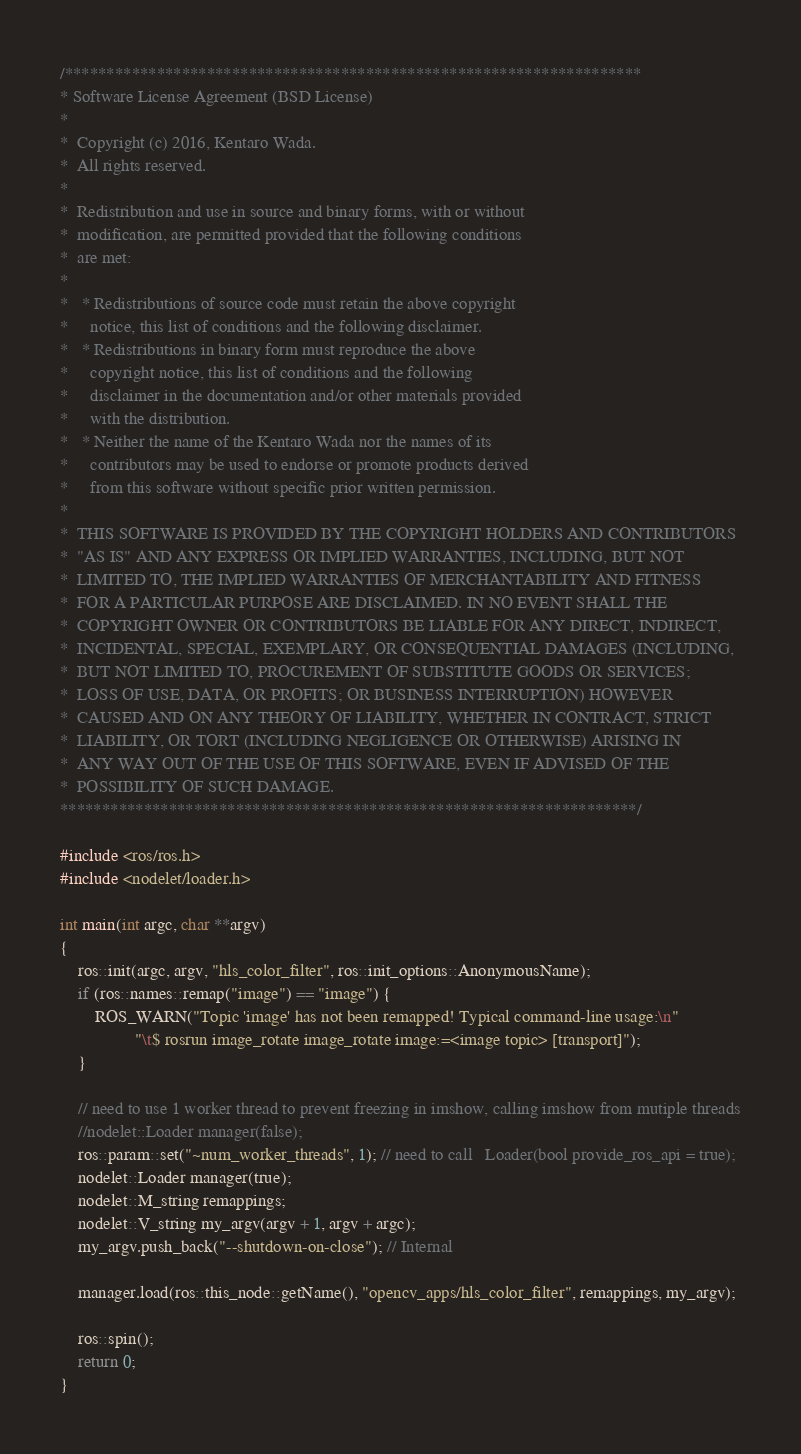Convert code to text. <code><loc_0><loc_0><loc_500><loc_500><_C++_>/*********************************************************************
* Software License Agreement (BSD License)
*
*  Copyright (c) 2016, Kentaro Wada.
*  All rights reserved.
*
*  Redistribution and use in source and binary forms, with or without
*  modification, are permitted provided that the following conditions
*  are met:
*
*   * Redistributions of source code must retain the above copyright
*     notice, this list of conditions and the following disclaimer.
*   * Redistributions in binary form must reproduce the above
*     copyright notice, this list of conditions and the following
*     disclaimer in the documentation and/or other materials provided
*     with the distribution.
*   * Neither the name of the Kentaro Wada nor the names of its
*     contributors may be used to endorse or promote products derived
*     from this software without specific prior written permission.
*
*  THIS SOFTWARE IS PROVIDED BY THE COPYRIGHT HOLDERS AND CONTRIBUTORS
*  "AS IS" AND ANY EXPRESS OR IMPLIED WARRANTIES, INCLUDING, BUT NOT
*  LIMITED TO, THE IMPLIED WARRANTIES OF MERCHANTABILITY AND FITNESS
*  FOR A PARTICULAR PURPOSE ARE DISCLAIMED. IN NO EVENT SHALL THE
*  COPYRIGHT OWNER OR CONTRIBUTORS BE LIABLE FOR ANY DIRECT, INDIRECT,
*  INCIDENTAL, SPECIAL, EXEMPLARY, OR CONSEQUENTIAL DAMAGES (INCLUDING,
*  BUT NOT LIMITED TO, PROCUREMENT OF SUBSTITUTE GOODS OR SERVICES;
*  LOSS OF USE, DATA, OR PROFITS; OR BUSINESS INTERRUPTION) HOWEVER
*  CAUSED AND ON ANY THEORY OF LIABILITY, WHETHER IN CONTRACT, STRICT
*  LIABILITY, OR TORT (INCLUDING NEGLIGENCE OR OTHERWISE) ARISING IN
*  ANY WAY OUT OF THE USE OF THIS SOFTWARE, EVEN IF ADVISED OF THE
*  POSSIBILITY OF SUCH DAMAGE.
*********************************************************************/

#include <ros/ros.h>
#include <nodelet/loader.h>

int main(int argc, char **argv)
{
    ros::init(argc, argv, "hls_color_filter", ros::init_options::AnonymousName);
    if (ros::names::remap("image") == "image") {
        ROS_WARN("Topic 'image' has not been remapped! Typical command-line usage:\n"
                 "\t$ rosrun image_rotate image_rotate image:=<image topic> [transport]");
    }

    // need to use 1 worker thread to prevent freezing in imshow, calling imshow from mutiple threads
    //nodelet::Loader manager(false);
    ros::param::set("~num_worker_threads", 1); // need to call   Loader(bool provide_ros_api = true);
    nodelet::Loader manager(true);
    nodelet::M_string remappings;
    nodelet::V_string my_argv(argv + 1, argv + argc);
    my_argv.push_back("--shutdown-on-close"); // Internal

    manager.load(ros::this_node::getName(), "opencv_apps/hls_color_filter", remappings, my_argv);

    ros::spin();
    return 0;
}
</code> 